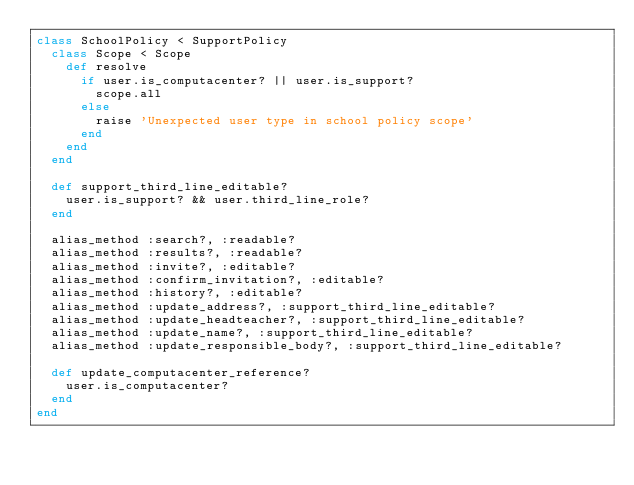<code> <loc_0><loc_0><loc_500><loc_500><_Ruby_>class SchoolPolicy < SupportPolicy
  class Scope < Scope
    def resolve
      if user.is_computacenter? || user.is_support?
        scope.all
      else
        raise 'Unexpected user type in school policy scope'
      end
    end
  end

  def support_third_line_editable?
    user.is_support? && user.third_line_role?
  end

  alias_method :search?, :readable?
  alias_method :results?, :readable?
  alias_method :invite?, :editable?
  alias_method :confirm_invitation?, :editable?
  alias_method :history?, :editable?
  alias_method :update_address?, :support_third_line_editable?
  alias_method :update_headteacher?, :support_third_line_editable?
  alias_method :update_name?, :support_third_line_editable?
  alias_method :update_responsible_body?, :support_third_line_editable?

  def update_computacenter_reference?
    user.is_computacenter?
  end
end
</code> 